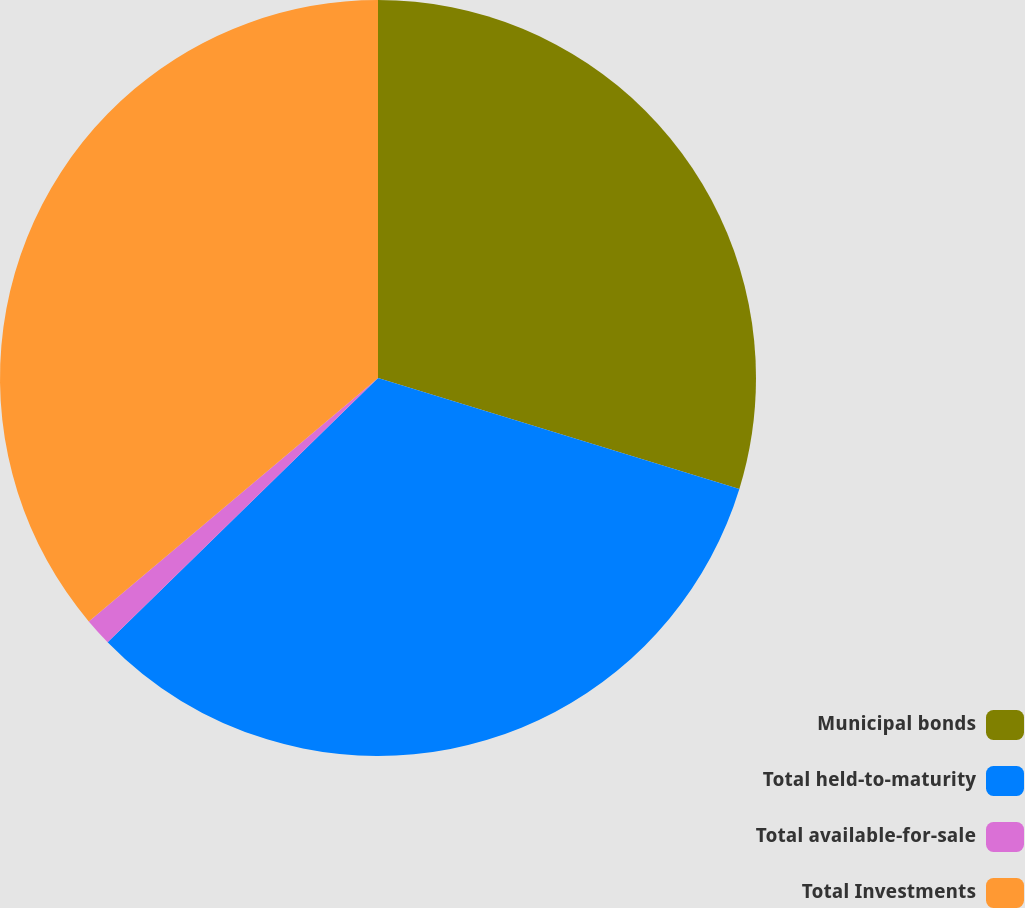<chart> <loc_0><loc_0><loc_500><loc_500><pie_chart><fcel>Municipal bonds<fcel>Total held-to-maturity<fcel>Total available-for-sale<fcel>Total Investments<nl><fcel>29.74%<fcel>32.94%<fcel>1.18%<fcel>36.13%<nl></chart> 